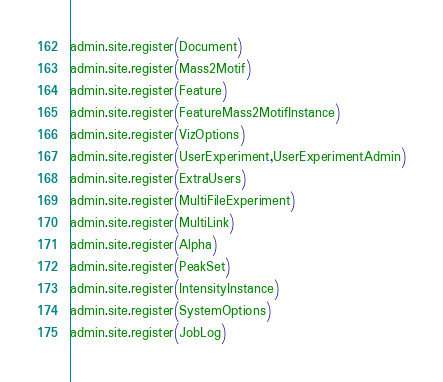<code> <loc_0><loc_0><loc_500><loc_500><_Python_>admin.site.register(Document)
admin.site.register(Mass2Motif)
admin.site.register(Feature)
admin.site.register(FeatureMass2MotifInstance)
admin.site.register(VizOptions)
admin.site.register(UserExperiment,UserExperimentAdmin)
admin.site.register(ExtraUsers)
admin.site.register(MultiFileExperiment)
admin.site.register(MultiLink)
admin.site.register(Alpha)
admin.site.register(PeakSet)
admin.site.register(IntensityInstance)
admin.site.register(SystemOptions)
admin.site.register(JobLog)
</code> 